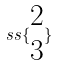<formula> <loc_0><loc_0><loc_500><loc_500>s s \{ \begin{matrix} 2 \\ 3 \end{matrix} \}</formula> 